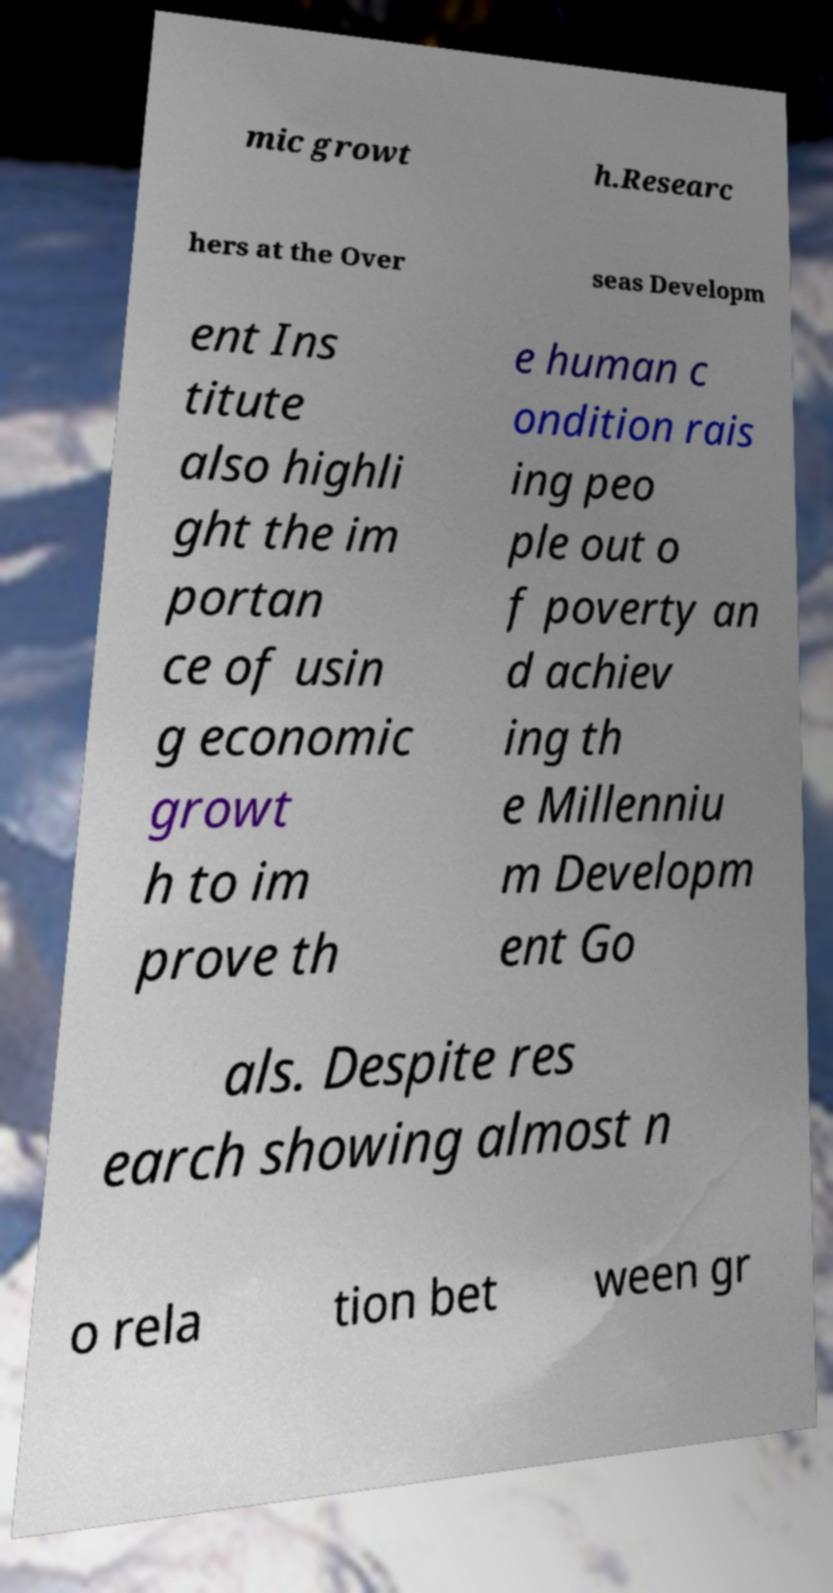Could you extract and type out the text from this image? mic growt h.Researc hers at the Over seas Developm ent Ins titute also highli ght the im portan ce of usin g economic growt h to im prove th e human c ondition rais ing peo ple out o f poverty an d achiev ing th e Millenniu m Developm ent Go als. Despite res earch showing almost n o rela tion bet ween gr 